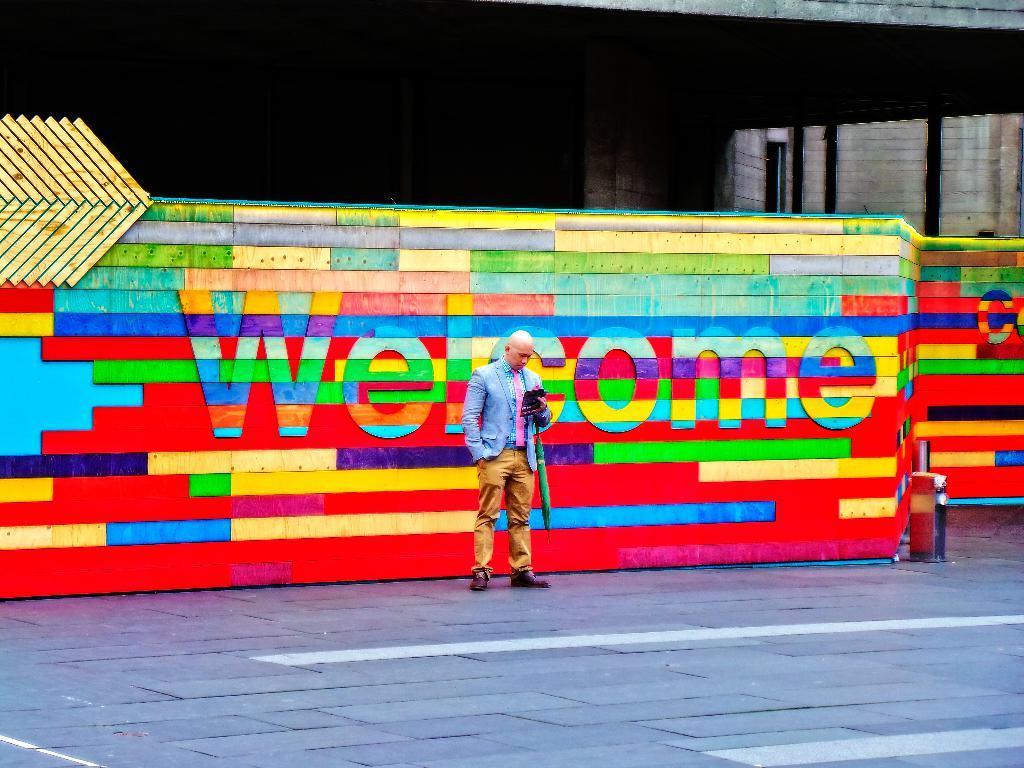How would you summarize this image in a sentence or two? In this image, we can see a person in front of the wall. This person is standing and wearing clothes. There is a colorful text on the wall. There is a building in the top right of the image. 